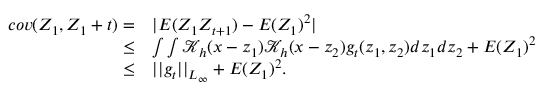Convert formula to latex. <formula><loc_0><loc_0><loc_500><loc_500>\begin{array} { r l } { c o v ( Z _ { 1 } , Z _ { 1 } + t ) = } & { | E ( Z _ { 1 } Z _ { t + 1 } ) - E ( Z _ { 1 } ) ^ { 2 } | } \\ { \leq } & { \int \int \mathcal { K } _ { h } ( x - z _ { 1 } ) \mathcal { K } _ { h } ( x - z _ { 2 } ) g _ { t } ( z _ { 1 } , z _ { 2 } ) d z _ { 1 } d z _ { 2 } + E ( Z _ { 1 } ) ^ { 2 } } \\ { \leq } & { | | g _ { t } | | _ { L _ { \infty } } + E ( Z _ { 1 } ) ^ { 2 } . } \end{array}</formula> 